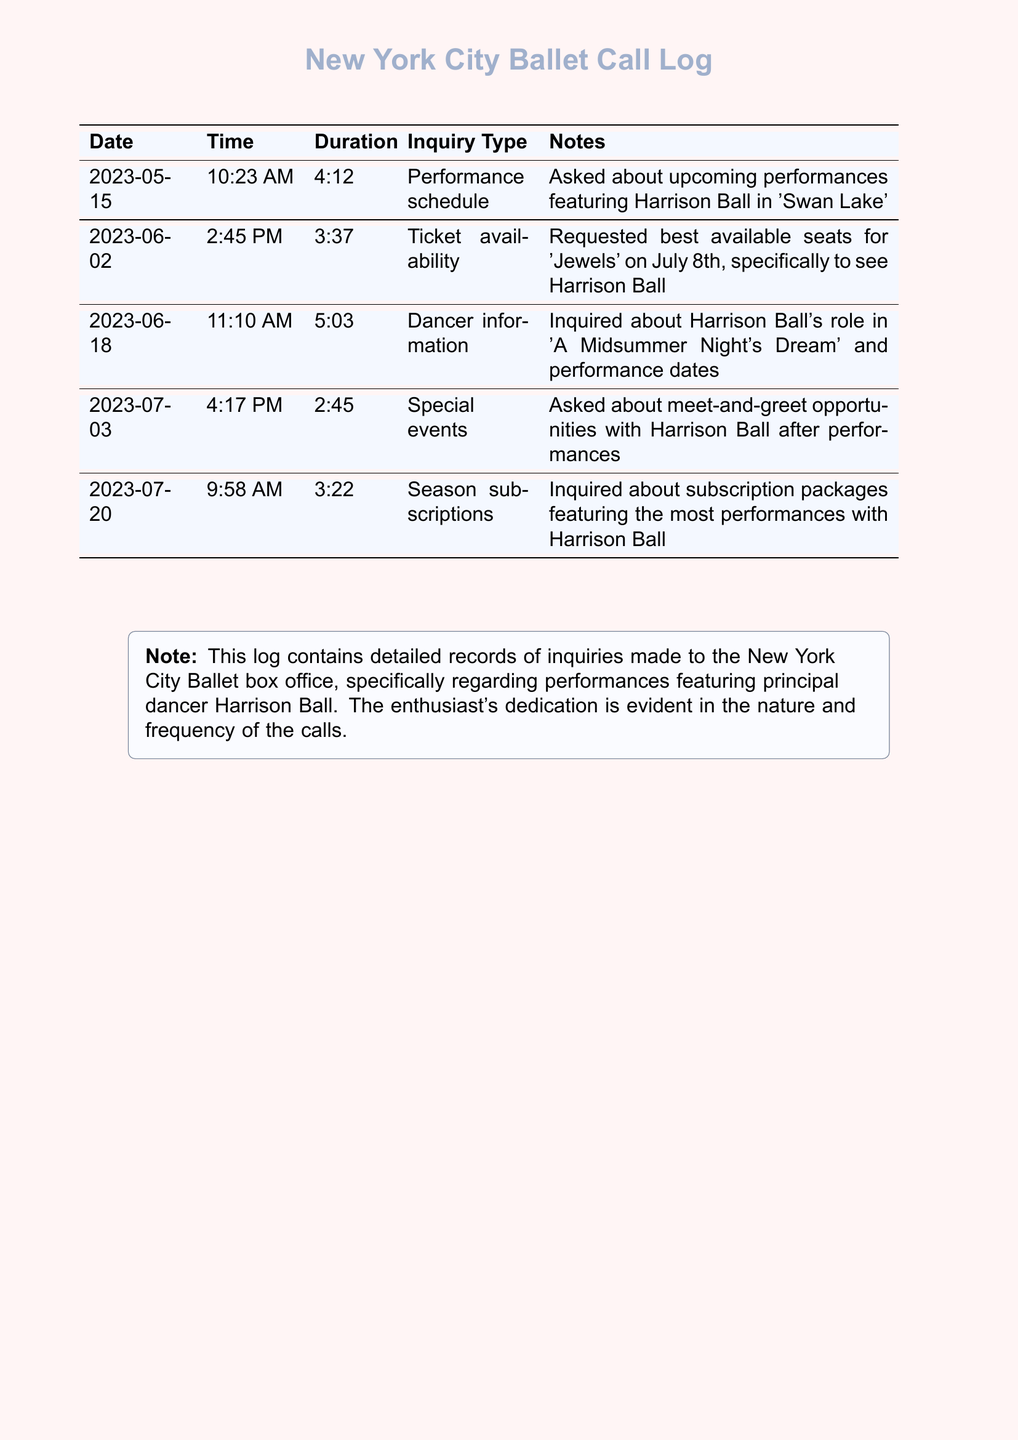what was the date of the call about 'Swan Lake'? The inquiry about 'Swan Lake' was made on May 15, 2023, as indicated in the document.
Answer: May 15, 2023 how long was the call regarding the special events? The duration of the call about meet-and-greet opportunities was 2 minutes and 45 seconds, as detailed in the log.
Answer: 2:45 which performance was inquired about on June 18th? On June 18th, the call was about Harrison Ball's role in 'A Midsummer Night's Dream'.
Answer: A Midsummer Night's Dream what time was the inquiry about ticket availability? The ticket availability inquiry occurred at 2:45 PM on June 2nd, as listed in the records.
Answer: 2:45 PM how many calls were made specifically about Harrison Ball? Counting all the entries, there are five calls regarding Harrison Ball as mentioned throughout the document.
Answer: Five 